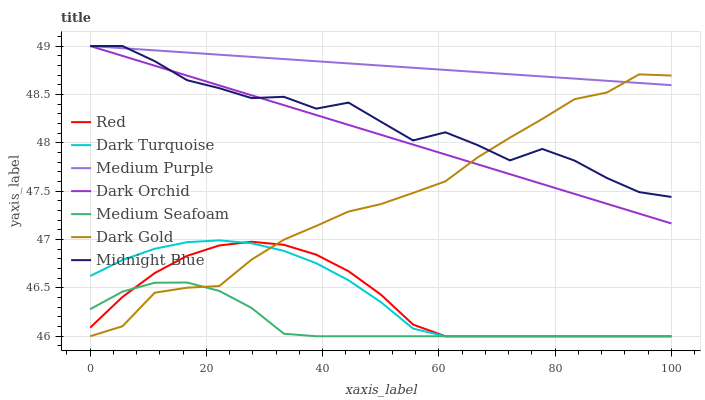Does Medium Seafoam have the minimum area under the curve?
Answer yes or no. Yes. Does Dark Gold have the minimum area under the curve?
Answer yes or no. No. Does Dark Gold have the maximum area under the curve?
Answer yes or no. No. Is Midnight Blue the roughest?
Answer yes or no. Yes. Is Dark Gold the smoothest?
Answer yes or no. No. Is Dark Gold the roughest?
Answer yes or no. No. Does Dark Orchid have the lowest value?
Answer yes or no. No. Does Dark Gold have the highest value?
Answer yes or no. No. Is Medium Seafoam less than Medium Purple?
Answer yes or no. Yes. Is Midnight Blue greater than Dark Turquoise?
Answer yes or no. Yes. Does Medium Seafoam intersect Medium Purple?
Answer yes or no. No. 